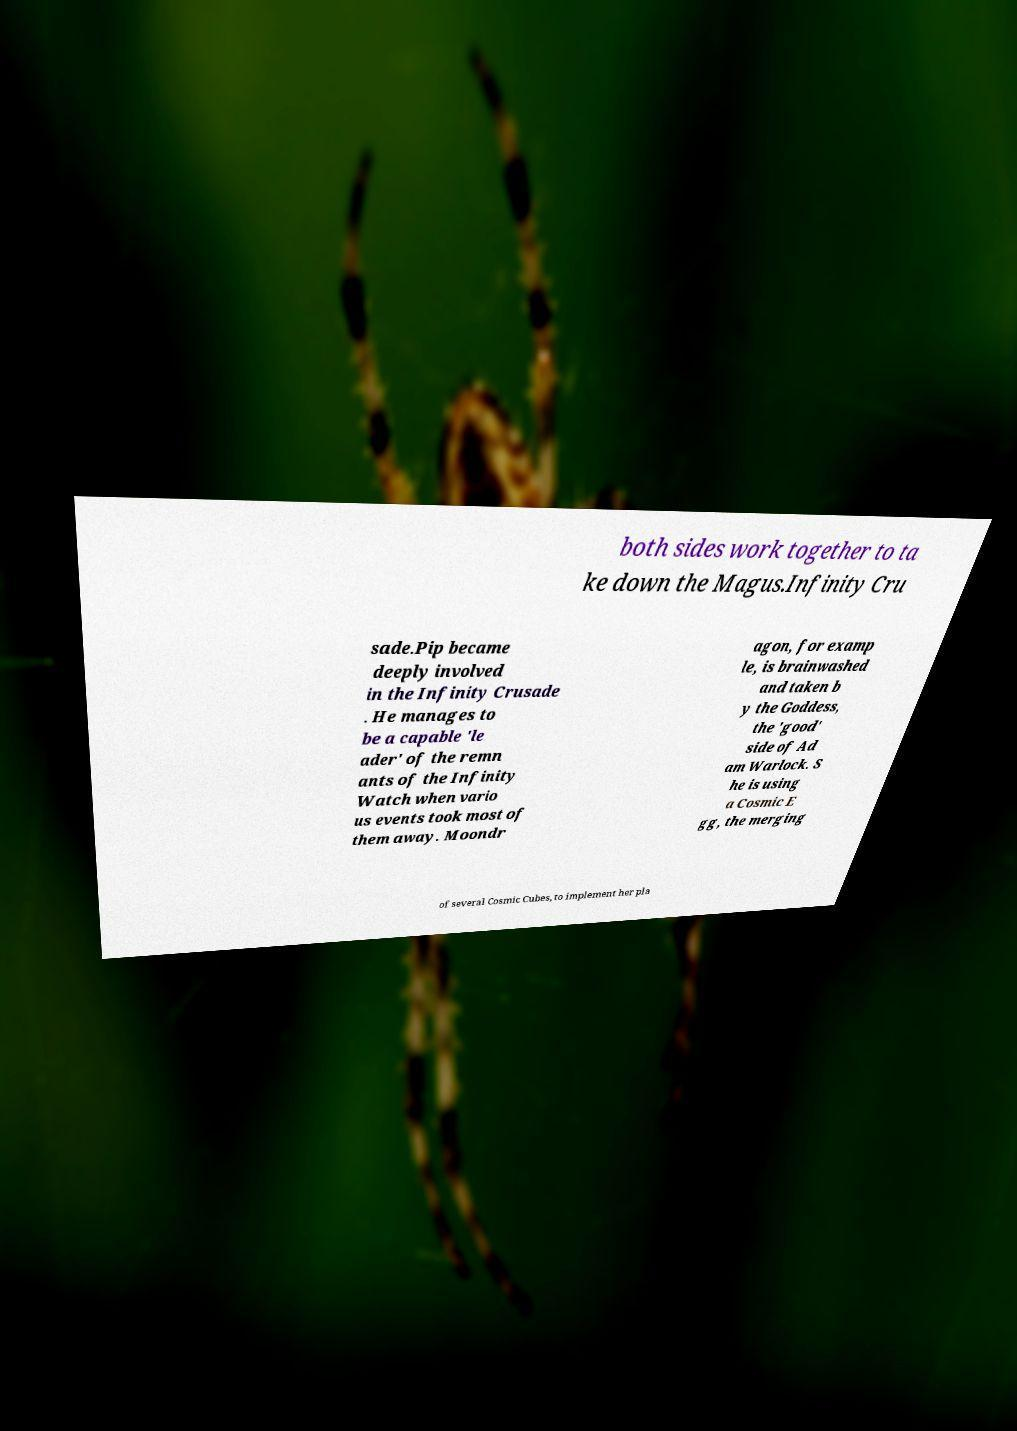Can you read and provide the text displayed in the image?This photo seems to have some interesting text. Can you extract and type it out for me? both sides work together to ta ke down the Magus.Infinity Cru sade.Pip became deeply involved in the Infinity Crusade . He manages to be a capable 'le ader' of the remn ants of the Infinity Watch when vario us events took most of them away. Moondr agon, for examp le, is brainwashed and taken b y the Goddess, the 'good' side of Ad am Warlock. S he is using a Cosmic E gg, the merging of several Cosmic Cubes, to implement her pla 